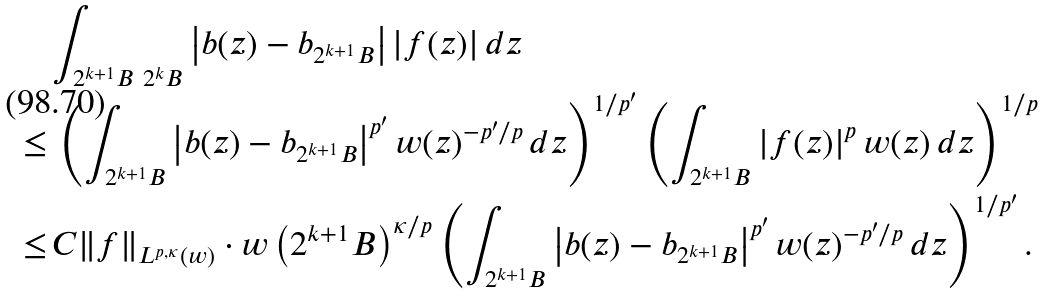<formula> <loc_0><loc_0><loc_500><loc_500>& \int _ { 2 ^ { k + 1 } B \ 2 ^ { k } B } \left | b ( z ) - b _ { 2 ^ { k + 1 } B } \right | | f ( z ) | \, d z \\ \leq & \, \left ( \int _ { 2 ^ { k + 1 } B } \left | b ( z ) - b _ { 2 ^ { k + 1 } B } \right | ^ { p ^ { \prime } } w ( z ) ^ { - { p ^ { \prime } } / p } \, d z \right ) ^ { 1 / { p ^ { \prime } } } \left ( \int _ { 2 ^ { k + 1 } B } \left | f ( z ) \right | ^ { p } w ( z ) \, d z \right ) ^ { 1 / p } \\ \leq & \, C \| f \| _ { L ^ { p , \kappa } ( w ) } \cdot w \left ( 2 ^ { k + 1 } B \right ) ^ { \kappa / p } \left ( \int _ { 2 ^ { k + 1 } B } \left | b ( z ) - b _ { 2 ^ { k + 1 } B } \right | ^ { p ^ { \prime } } w ( z ) ^ { - { p ^ { \prime } } / p } \, d z \right ) ^ { 1 / { p ^ { \prime } } } .</formula> 